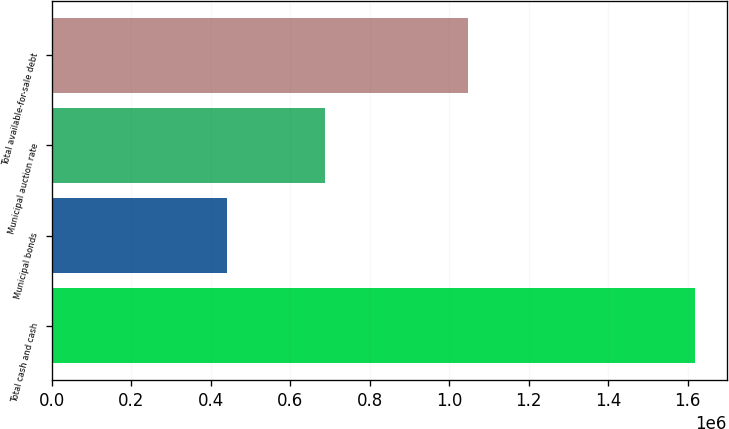Convert chart to OTSL. <chart><loc_0><loc_0><loc_500><loc_500><bar_chart><fcel>Total cash and cash<fcel>Municipal bonds<fcel>Municipal auction rate<fcel>Total available-for-sale debt<nl><fcel>1.61801e+06<fcel>442095<fcel>687134<fcel>1.04847e+06<nl></chart> 